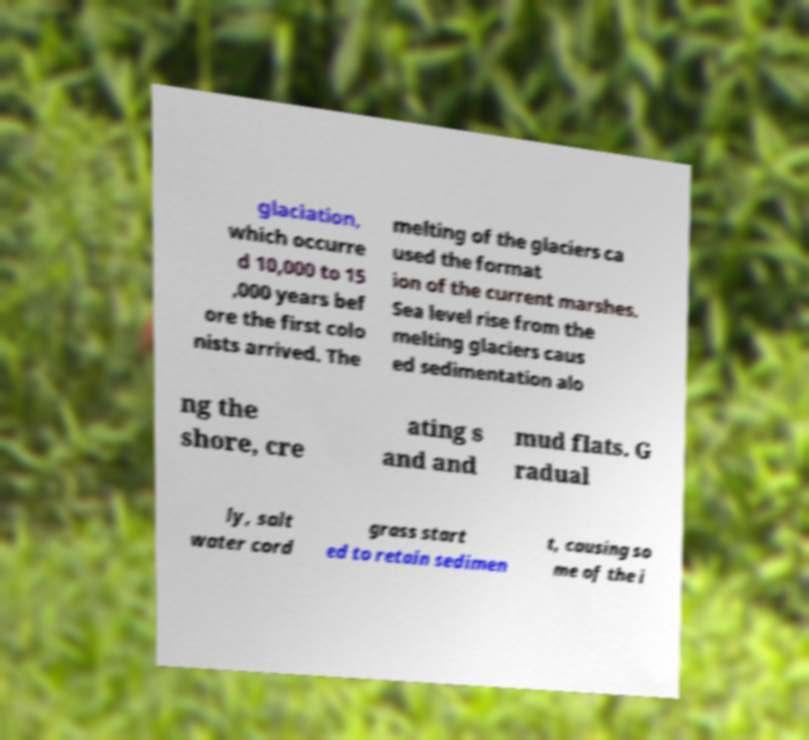Please read and relay the text visible in this image. What does it say? glaciation, which occurre d 10,000 to 15 ,000 years bef ore the first colo nists arrived. The melting of the glaciers ca used the format ion of the current marshes. Sea level rise from the melting glaciers caus ed sedimentation alo ng the shore, cre ating s and and mud flats. G radual ly, salt water cord grass start ed to retain sedimen t, causing so me of the i 